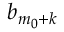Convert formula to latex. <formula><loc_0><loc_0><loc_500><loc_500>b _ { m _ { 0 } + k }</formula> 